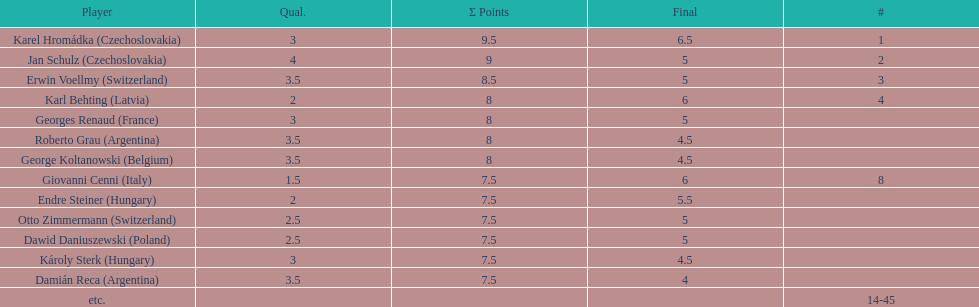Karl behting and giovanni cenni each had final scores of what? 6. 